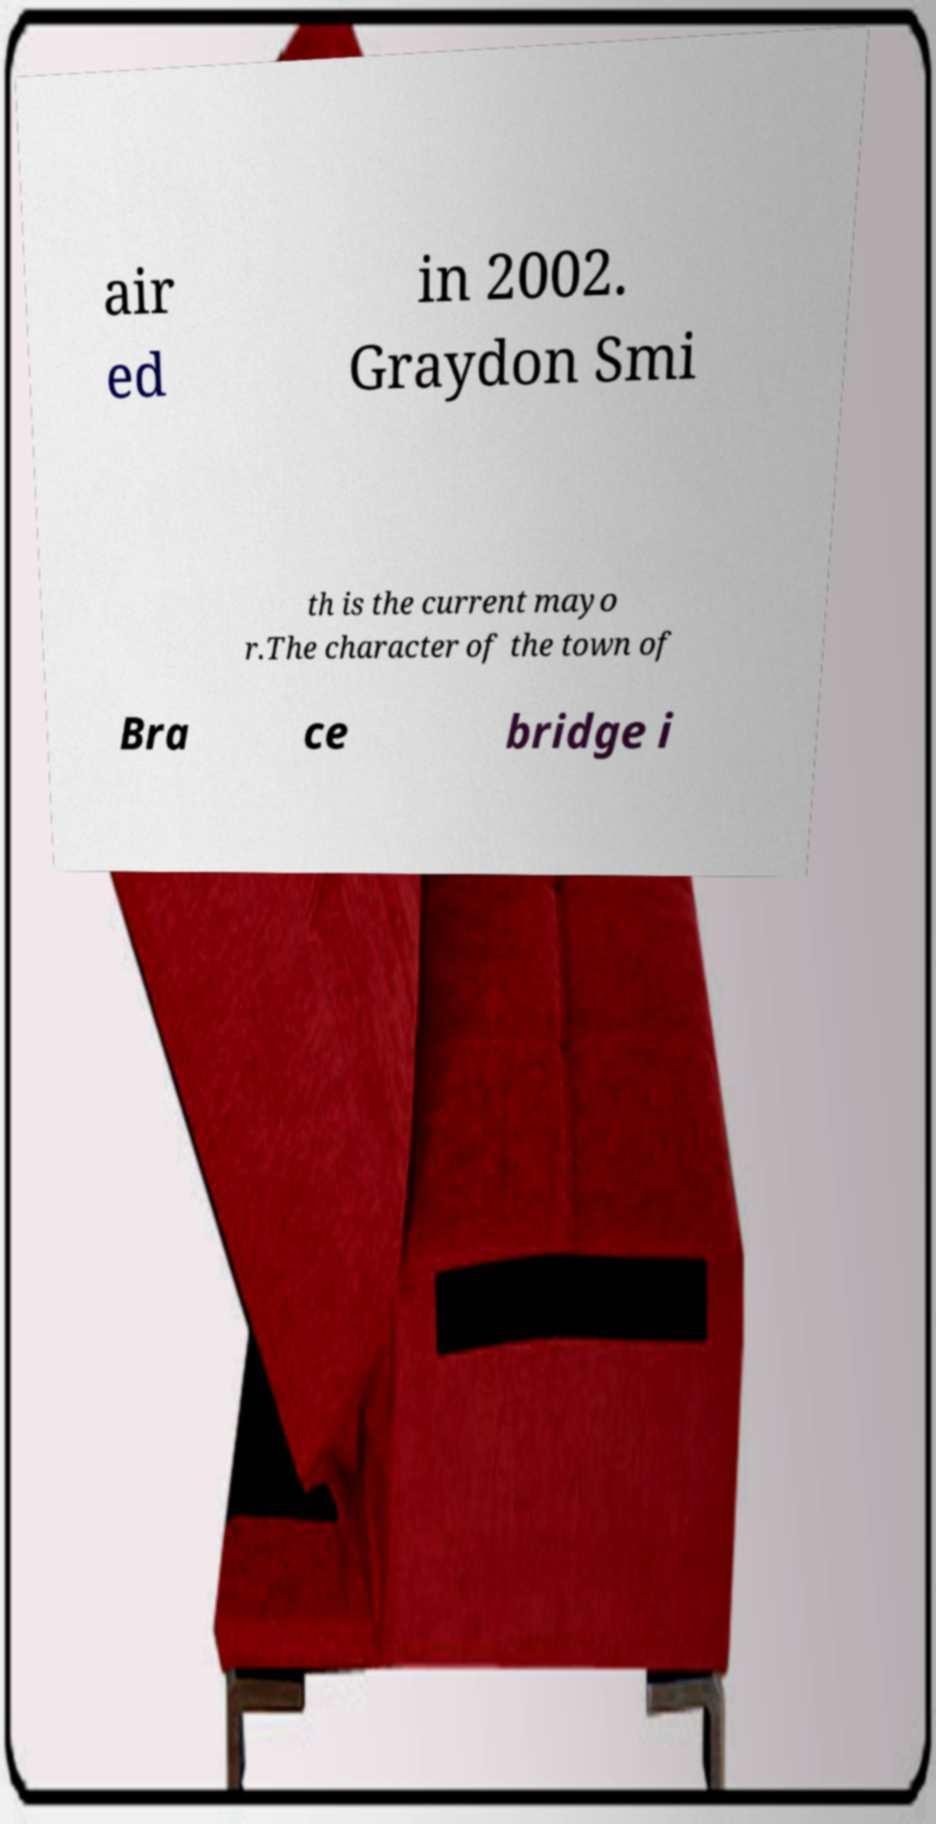There's text embedded in this image that I need extracted. Can you transcribe it verbatim? air ed in 2002. Graydon Smi th is the current mayo r.The character of the town of Bra ce bridge i 